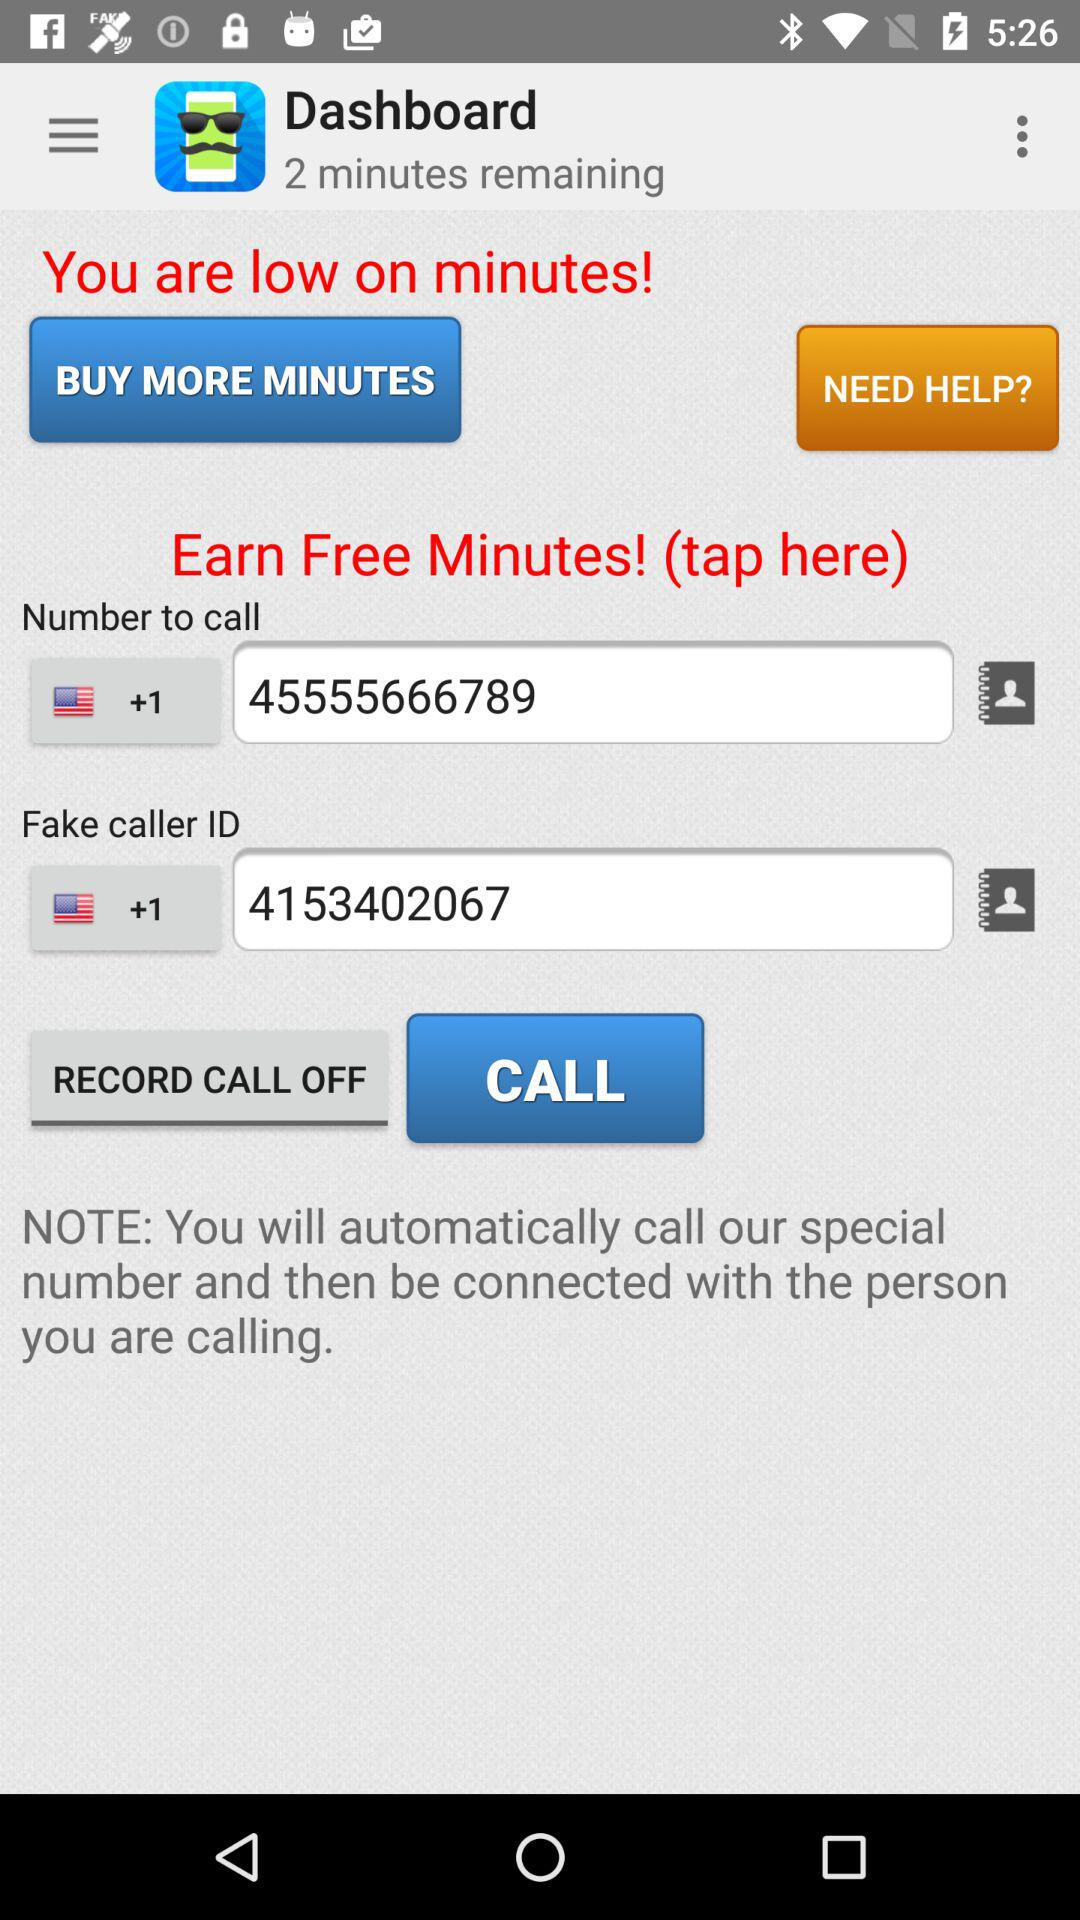What is the contact number? The contact numbers are +1 45555666789 and +1 4153402067. 